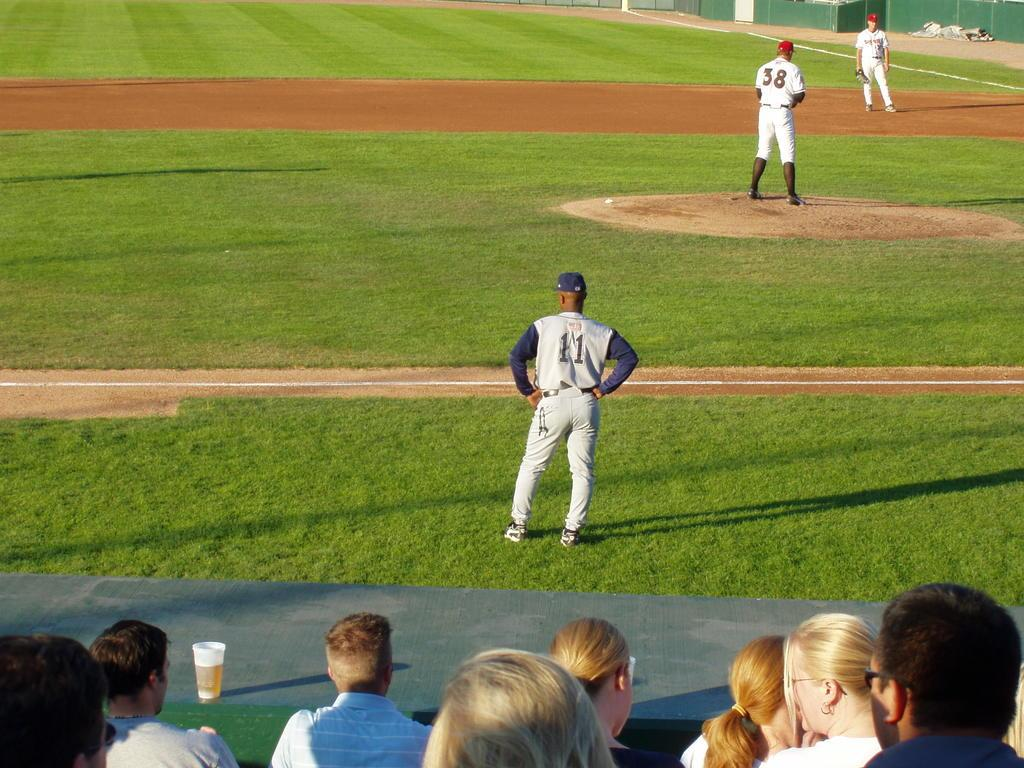<image>
Render a clear and concise summary of the photo. Spectators watch as players wearing numbers 11 and 38 take part in a baseball game. 